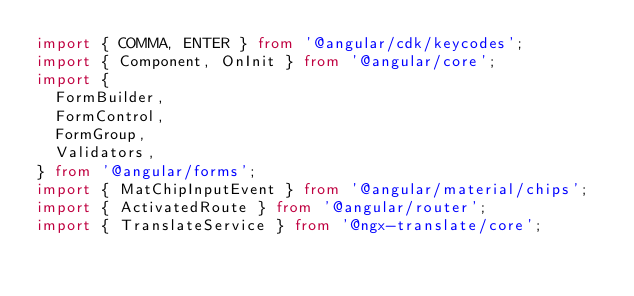<code> <loc_0><loc_0><loc_500><loc_500><_TypeScript_>import { COMMA, ENTER } from '@angular/cdk/keycodes';
import { Component, OnInit } from '@angular/core';
import {
  FormBuilder,
  FormControl,
  FormGroup,
  Validators,
} from '@angular/forms';
import { MatChipInputEvent } from '@angular/material/chips';
import { ActivatedRoute } from '@angular/router';
import { TranslateService } from '@ngx-translate/core';</code> 